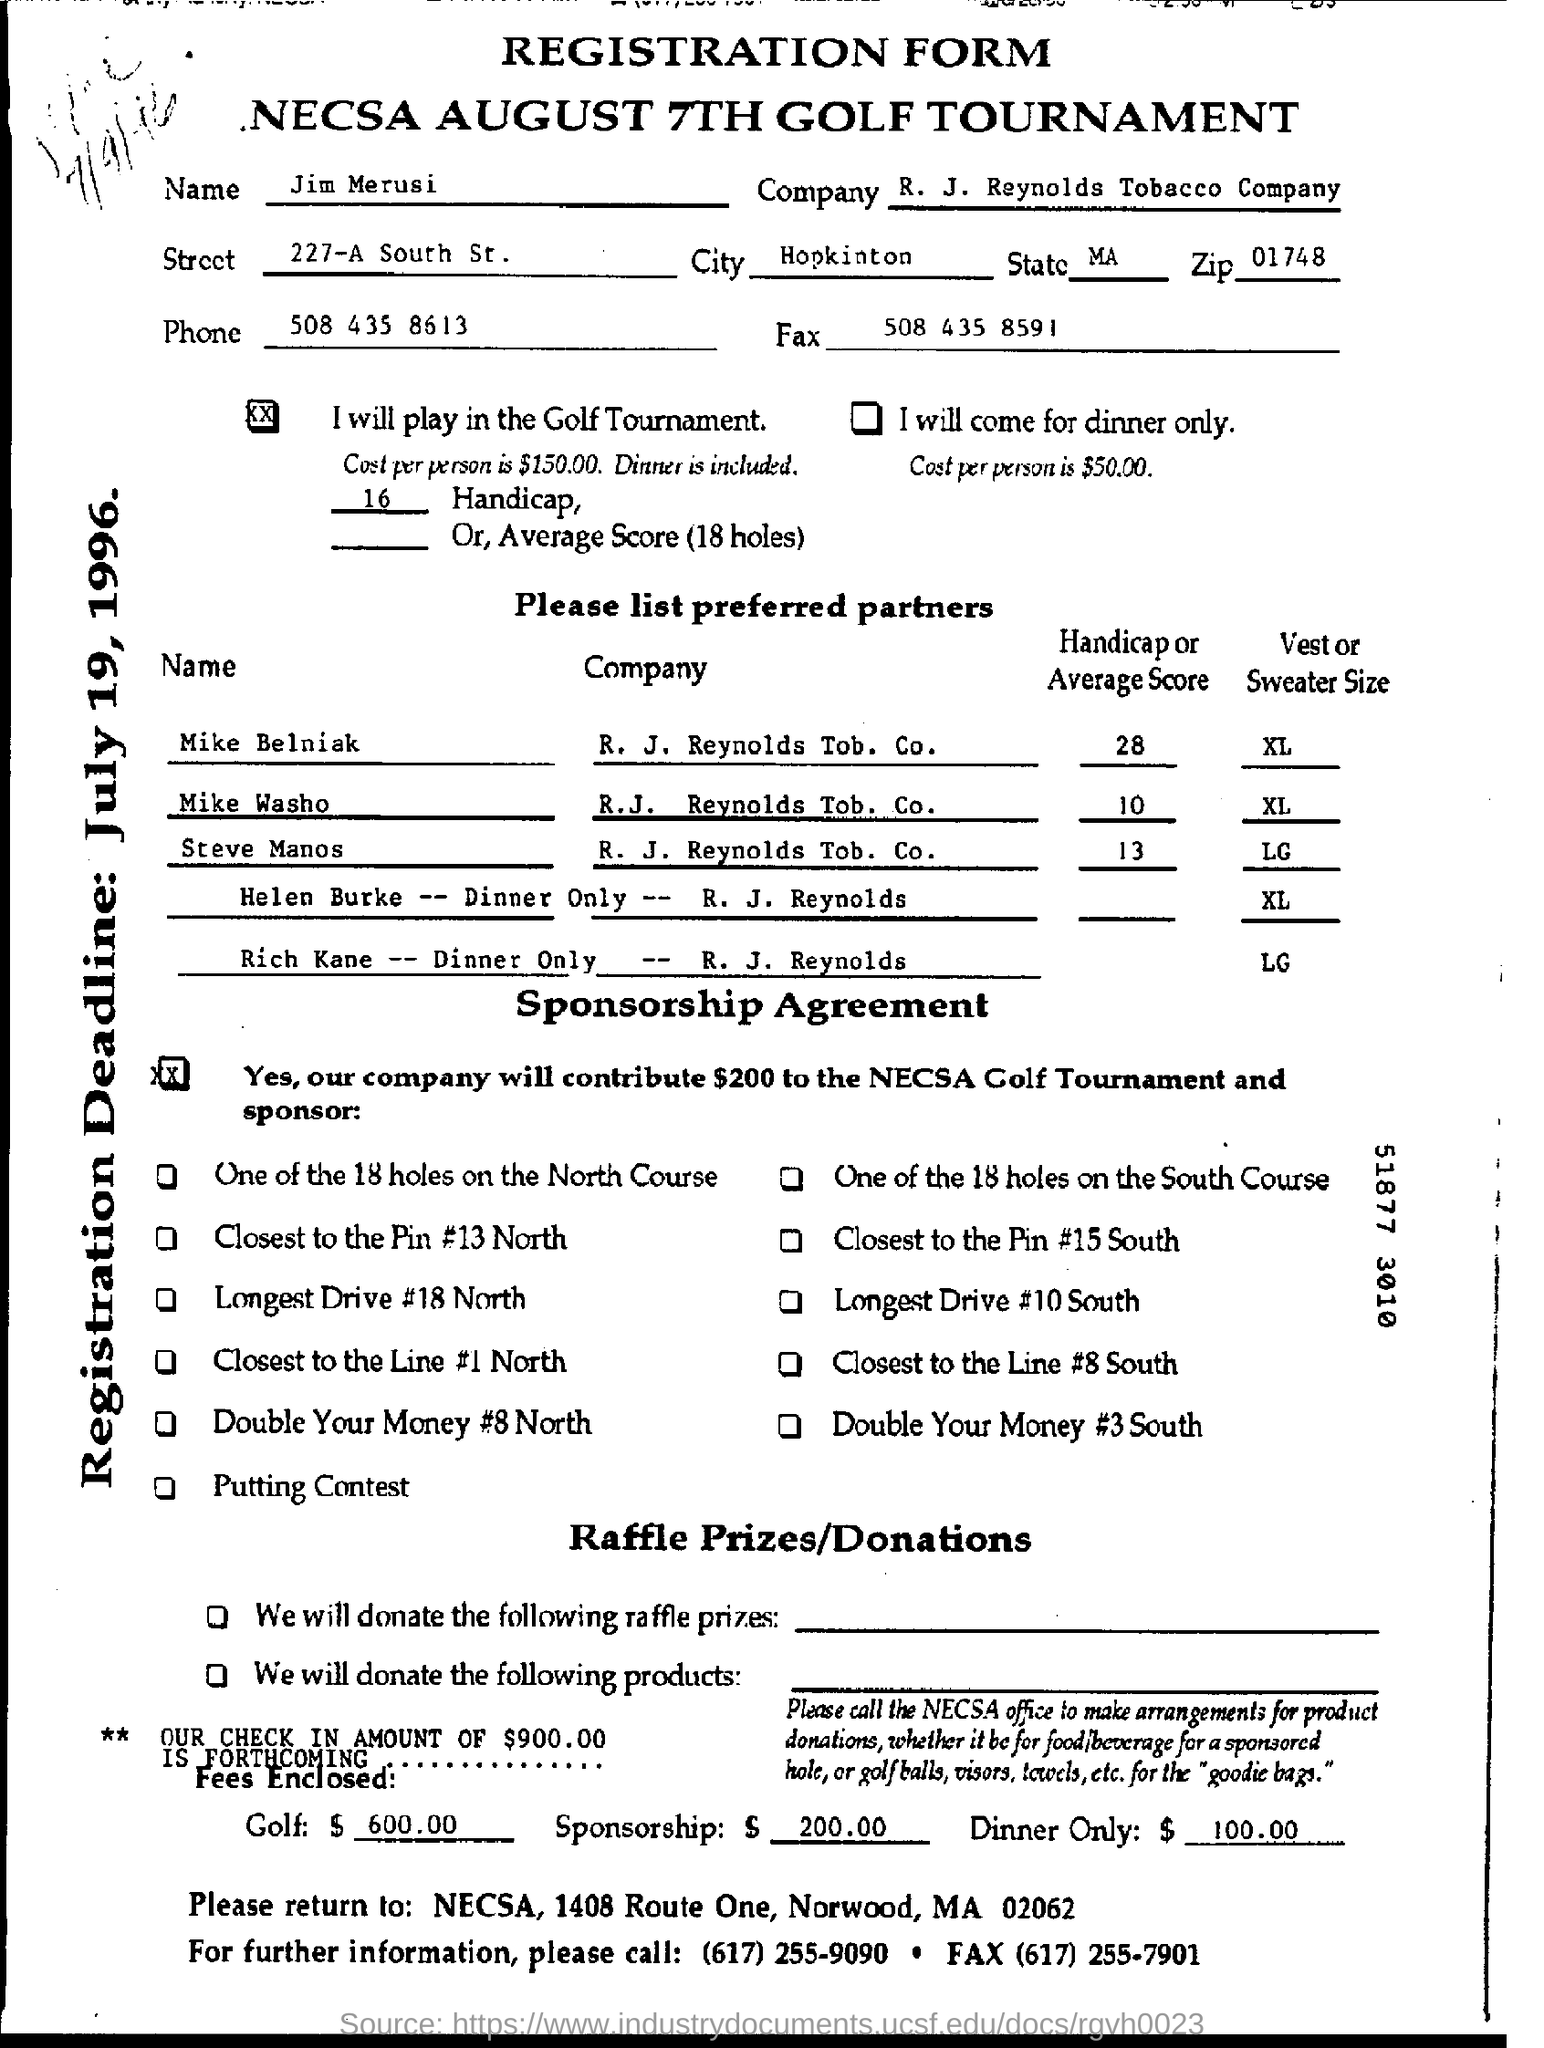What is the name of the tournament?
Provide a succinct answer. Necsa august 7th golf tournament. What is the zip code?
Your answer should be very brief. 01748. What is the phone number of the jim merusi?
Provide a succinct answer. 508 435 8613. What is the fax number?
Your answer should be compact. 508 435 8591. 